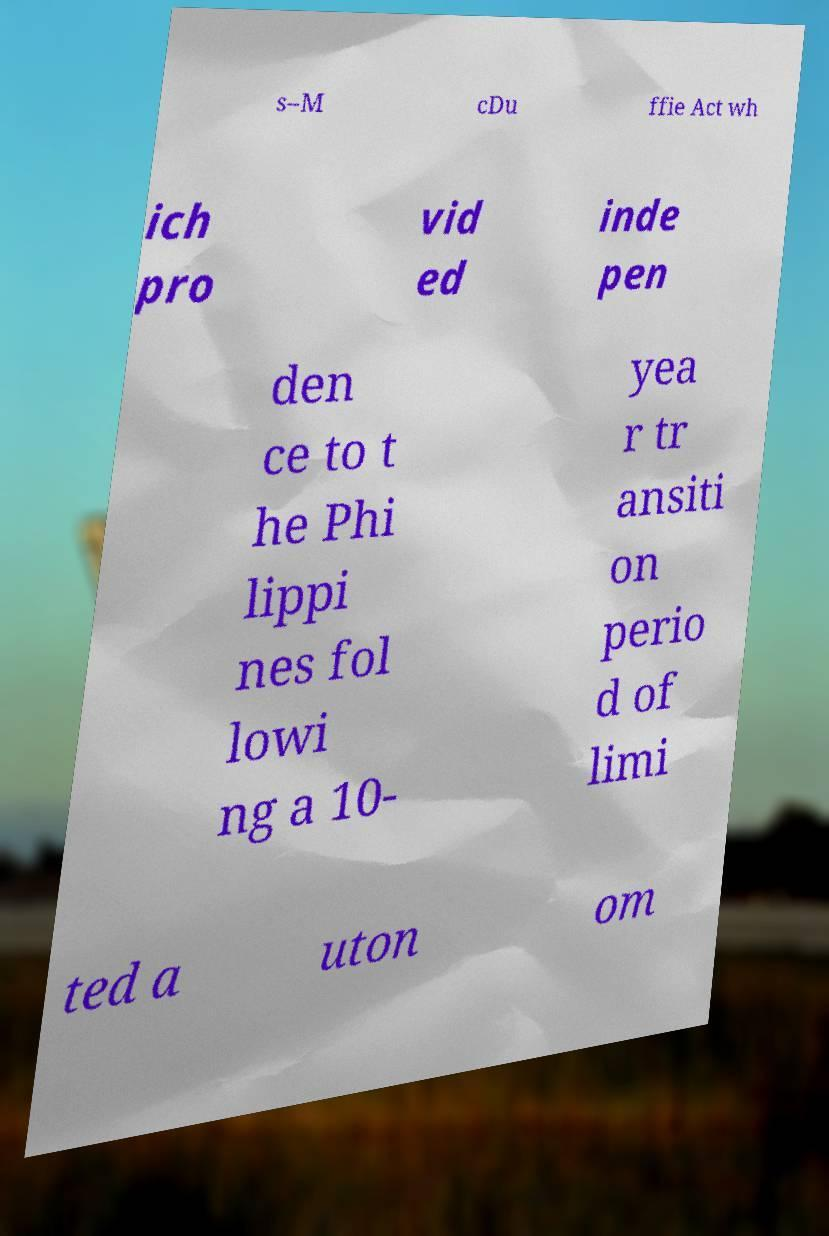Could you assist in decoding the text presented in this image and type it out clearly? s–M cDu ffie Act wh ich pro vid ed inde pen den ce to t he Phi lippi nes fol lowi ng a 10- yea r tr ansiti on perio d of limi ted a uton om 